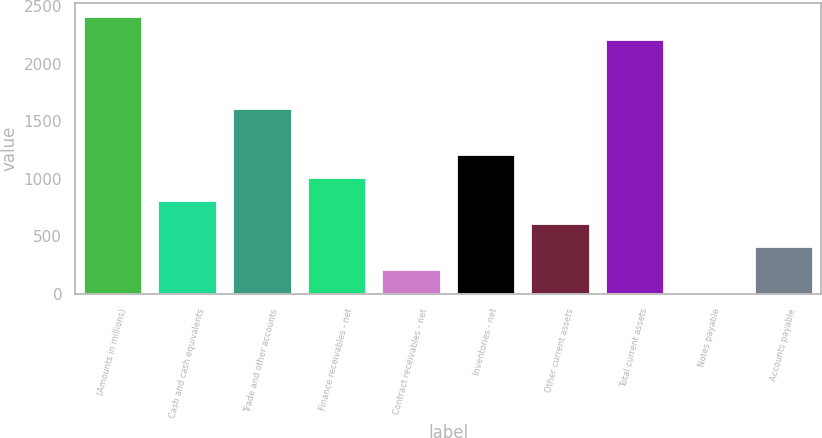<chart> <loc_0><loc_0><loc_500><loc_500><bar_chart><fcel>(Amounts in millions)<fcel>Cash and cash equivalents<fcel>Trade and other accounts<fcel>Finance receivables - net<fcel>Contract receivables - net<fcel>Inventories - net<fcel>Other current assets<fcel>Total current assets<fcel>Notes payable<fcel>Accounts payable<nl><fcel>2409.96<fcel>814.12<fcel>1612.04<fcel>1013.6<fcel>215.68<fcel>1213.08<fcel>614.64<fcel>2210.48<fcel>16.2<fcel>415.16<nl></chart> 